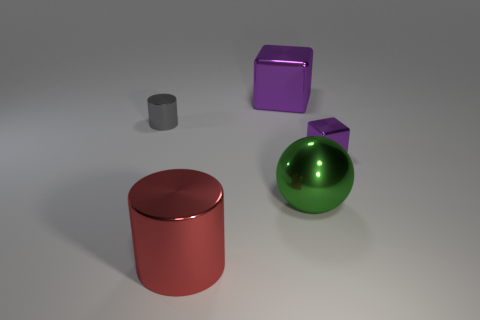How many purple cubes must be subtracted to get 1 purple cubes? 1 Add 3 small gray things. How many objects exist? 8 Subtract all big brown spheres. Subtract all large metallic spheres. How many objects are left? 4 Add 4 small purple things. How many small purple things are left? 5 Add 3 gray objects. How many gray objects exist? 4 Subtract 0 cyan cubes. How many objects are left? 5 Subtract all blocks. How many objects are left? 3 